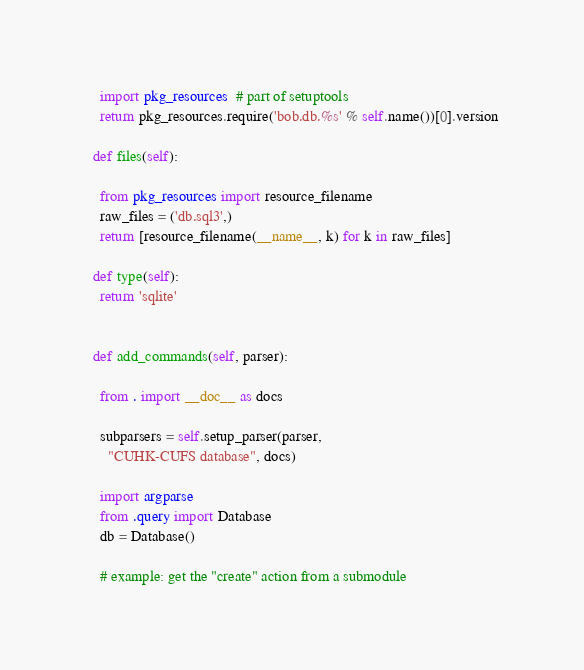<code> <loc_0><loc_0><loc_500><loc_500><_Python_>    import pkg_resources  # part of setuptools
    return pkg_resources.require('bob.db.%s' % self.name())[0].version

  def files(self):

    from pkg_resources import resource_filename
    raw_files = ('db.sql3',)
    return [resource_filename(__name__, k) for k in raw_files]

  def type(self):
    return 'sqlite'


  def add_commands(self, parser):

    from . import __doc__ as docs

    subparsers = self.setup_parser(parser,
      "CUHK-CUFS database", docs)

    import argparse
    from .query import Database
    db = Database()

    # example: get the "create" action from a submodule</code> 